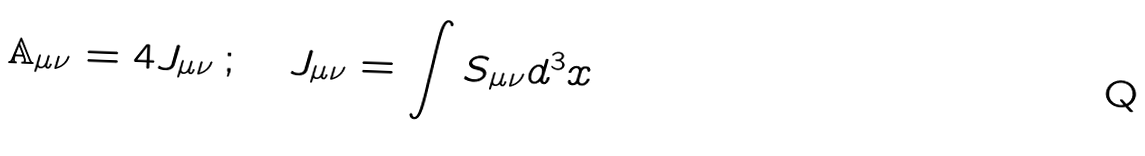Convert formula to latex. <formula><loc_0><loc_0><loc_500><loc_500>\mathbb { A } _ { \mu \nu } = 4 J _ { \mu \nu } \, ; \quad J _ { \mu \nu } = \int S _ { \mu \nu } d ^ { 3 } x</formula> 